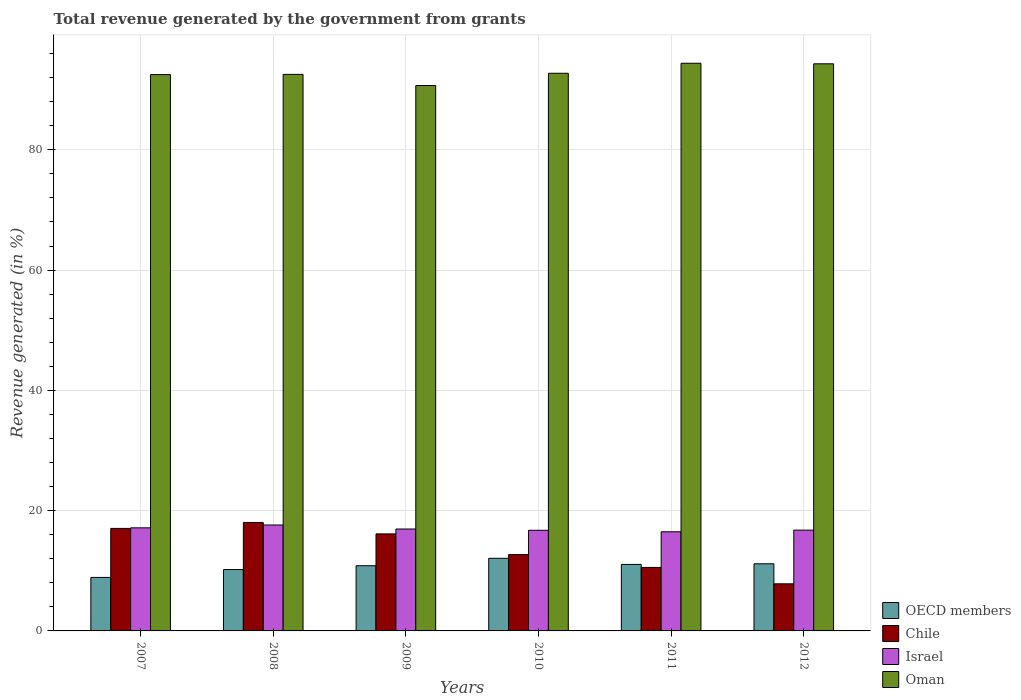How many groups of bars are there?
Give a very brief answer. 6. Are the number of bars on each tick of the X-axis equal?
Provide a short and direct response. Yes. How many bars are there on the 6th tick from the left?
Give a very brief answer. 4. In how many cases, is the number of bars for a given year not equal to the number of legend labels?
Provide a short and direct response. 0. What is the total revenue generated in OECD members in 2010?
Your response must be concise. 12.08. Across all years, what is the maximum total revenue generated in Israel?
Offer a terse response. 17.61. Across all years, what is the minimum total revenue generated in Oman?
Your answer should be compact. 90.69. In which year was the total revenue generated in OECD members minimum?
Provide a succinct answer. 2007. What is the total total revenue generated in OECD members in the graph?
Provide a succinct answer. 64.24. What is the difference between the total revenue generated in Oman in 2008 and that in 2012?
Your response must be concise. -1.76. What is the difference between the total revenue generated in Oman in 2008 and the total revenue generated in Israel in 2012?
Make the answer very short. 75.78. What is the average total revenue generated in Chile per year?
Offer a very short reply. 13.72. In the year 2008, what is the difference between the total revenue generated in Oman and total revenue generated in Israel?
Give a very brief answer. 74.93. What is the ratio of the total revenue generated in Chile in 2011 to that in 2012?
Ensure brevity in your answer.  1.35. Is the difference between the total revenue generated in Oman in 2007 and 2009 greater than the difference between the total revenue generated in Israel in 2007 and 2009?
Offer a terse response. Yes. What is the difference between the highest and the second highest total revenue generated in OECD members?
Offer a terse response. 0.91. What is the difference between the highest and the lowest total revenue generated in Chile?
Give a very brief answer. 10.2. In how many years, is the total revenue generated in Chile greater than the average total revenue generated in Chile taken over all years?
Your response must be concise. 3. What does the 3rd bar from the left in 2008 represents?
Your response must be concise. Israel. What does the 1st bar from the right in 2012 represents?
Your response must be concise. Oman. How many bars are there?
Your answer should be compact. 24. How many years are there in the graph?
Your answer should be very brief. 6. What is the difference between two consecutive major ticks on the Y-axis?
Give a very brief answer. 20. Does the graph contain any zero values?
Your answer should be very brief. No. Does the graph contain grids?
Your answer should be very brief. Yes. Where does the legend appear in the graph?
Provide a short and direct response. Bottom right. How many legend labels are there?
Provide a succinct answer. 4. How are the legend labels stacked?
Your response must be concise. Vertical. What is the title of the graph?
Your answer should be compact. Total revenue generated by the government from grants. Does "Europe(all income levels)" appear as one of the legend labels in the graph?
Offer a very short reply. No. What is the label or title of the X-axis?
Offer a very short reply. Years. What is the label or title of the Y-axis?
Make the answer very short. Revenue generated (in %). What is the Revenue generated (in %) of OECD members in 2007?
Make the answer very short. 8.9. What is the Revenue generated (in %) in Chile in 2007?
Provide a short and direct response. 17.05. What is the Revenue generated (in %) in Israel in 2007?
Your answer should be very brief. 17.14. What is the Revenue generated (in %) of Oman in 2007?
Ensure brevity in your answer.  92.51. What is the Revenue generated (in %) of OECD members in 2008?
Make the answer very short. 10.2. What is the Revenue generated (in %) in Chile in 2008?
Provide a short and direct response. 18.03. What is the Revenue generated (in %) of Israel in 2008?
Give a very brief answer. 17.61. What is the Revenue generated (in %) in Oman in 2008?
Provide a short and direct response. 92.54. What is the Revenue generated (in %) in OECD members in 2009?
Your answer should be very brief. 10.84. What is the Revenue generated (in %) in Chile in 2009?
Make the answer very short. 16.14. What is the Revenue generated (in %) of Israel in 2009?
Keep it short and to the point. 16.95. What is the Revenue generated (in %) of Oman in 2009?
Your response must be concise. 90.69. What is the Revenue generated (in %) in OECD members in 2010?
Keep it short and to the point. 12.08. What is the Revenue generated (in %) of Chile in 2010?
Your answer should be very brief. 12.7. What is the Revenue generated (in %) in Israel in 2010?
Give a very brief answer. 16.73. What is the Revenue generated (in %) in Oman in 2010?
Give a very brief answer. 92.72. What is the Revenue generated (in %) of OECD members in 2011?
Your answer should be very brief. 11.06. What is the Revenue generated (in %) of Chile in 2011?
Your answer should be compact. 10.56. What is the Revenue generated (in %) in Israel in 2011?
Keep it short and to the point. 16.48. What is the Revenue generated (in %) of Oman in 2011?
Make the answer very short. 94.39. What is the Revenue generated (in %) of OECD members in 2012?
Ensure brevity in your answer.  11.16. What is the Revenue generated (in %) of Chile in 2012?
Your response must be concise. 7.83. What is the Revenue generated (in %) of Israel in 2012?
Keep it short and to the point. 16.76. What is the Revenue generated (in %) in Oman in 2012?
Offer a very short reply. 94.3. Across all years, what is the maximum Revenue generated (in %) in OECD members?
Your answer should be compact. 12.08. Across all years, what is the maximum Revenue generated (in %) in Chile?
Make the answer very short. 18.03. Across all years, what is the maximum Revenue generated (in %) of Israel?
Make the answer very short. 17.61. Across all years, what is the maximum Revenue generated (in %) of Oman?
Keep it short and to the point. 94.39. Across all years, what is the minimum Revenue generated (in %) in OECD members?
Provide a short and direct response. 8.9. Across all years, what is the minimum Revenue generated (in %) in Chile?
Provide a short and direct response. 7.83. Across all years, what is the minimum Revenue generated (in %) of Israel?
Offer a terse response. 16.48. Across all years, what is the minimum Revenue generated (in %) in Oman?
Provide a succinct answer. 90.69. What is the total Revenue generated (in %) of OECD members in the graph?
Offer a terse response. 64.24. What is the total Revenue generated (in %) of Chile in the graph?
Offer a terse response. 82.3. What is the total Revenue generated (in %) in Israel in the graph?
Offer a very short reply. 101.68. What is the total Revenue generated (in %) of Oman in the graph?
Offer a terse response. 557.15. What is the difference between the Revenue generated (in %) in OECD members in 2007 and that in 2008?
Offer a terse response. -1.3. What is the difference between the Revenue generated (in %) in Chile in 2007 and that in 2008?
Your response must be concise. -0.99. What is the difference between the Revenue generated (in %) of Israel in 2007 and that in 2008?
Ensure brevity in your answer.  -0.47. What is the difference between the Revenue generated (in %) of Oman in 2007 and that in 2008?
Ensure brevity in your answer.  -0.04. What is the difference between the Revenue generated (in %) of OECD members in 2007 and that in 2009?
Make the answer very short. -1.94. What is the difference between the Revenue generated (in %) in Chile in 2007 and that in 2009?
Ensure brevity in your answer.  0.91. What is the difference between the Revenue generated (in %) in Israel in 2007 and that in 2009?
Your answer should be compact. 0.2. What is the difference between the Revenue generated (in %) of Oman in 2007 and that in 2009?
Ensure brevity in your answer.  1.82. What is the difference between the Revenue generated (in %) of OECD members in 2007 and that in 2010?
Offer a terse response. -3.18. What is the difference between the Revenue generated (in %) of Chile in 2007 and that in 2010?
Your answer should be compact. 4.35. What is the difference between the Revenue generated (in %) in Israel in 2007 and that in 2010?
Keep it short and to the point. 0.41. What is the difference between the Revenue generated (in %) of Oman in 2007 and that in 2010?
Make the answer very short. -0.22. What is the difference between the Revenue generated (in %) in OECD members in 2007 and that in 2011?
Your response must be concise. -2.16. What is the difference between the Revenue generated (in %) of Chile in 2007 and that in 2011?
Your answer should be very brief. 6.49. What is the difference between the Revenue generated (in %) in Israel in 2007 and that in 2011?
Provide a short and direct response. 0.66. What is the difference between the Revenue generated (in %) of Oman in 2007 and that in 2011?
Make the answer very short. -1.89. What is the difference between the Revenue generated (in %) in OECD members in 2007 and that in 2012?
Ensure brevity in your answer.  -2.26. What is the difference between the Revenue generated (in %) of Chile in 2007 and that in 2012?
Ensure brevity in your answer.  9.21. What is the difference between the Revenue generated (in %) in Israel in 2007 and that in 2012?
Give a very brief answer. 0.38. What is the difference between the Revenue generated (in %) of Oman in 2007 and that in 2012?
Keep it short and to the point. -1.79. What is the difference between the Revenue generated (in %) in OECD members in 2008 and that in 2009?
Your answer should be very brief. -0.64. What is the difference between the Revenue generated (in %) of Chile in 2008 and that in 2009?
Make the answer very short. 1.9. What is the difference between the Revenue generated (in %) of Israel in 2008 and that in 2009?
Provide a short and direct response. 0.67. What is the difference between the Revenue generated (in %) of Oman in 2008 and that in 2009?
Ensure brevity in your answer.  1.85. What is the difference between the Revenue generated (in %) in OECD members in 2008 and that in 2010?
Make the answer very short. -1.88. What is the difference between the Revenue generated (in %) in Chile in 2008 and that in 2010?
Offer a very short reply. 5.34. What is the difference between the Revenue generated (in %) in Israel in 2008 and that in 2010?
Make the answer very short. 0.88. What is the difference between the Revenue generated (in %) in Oman in 2008 and that in 2010?
Offer a terse response. -0.18. What is the difference between the Revenue generated (in %) of OECD members in 2008 and that in 2011?
Offer a very short reply. -0.86. What is the difference between the Revenue generated (in %) in Chile in 2008 and that in 2011?
Keep it short and to the point. 7.48. What is the difference between the Revenue generated (in %) of Israel in 2008 and that in 2011?
Offer a very short reply. 1.13. What is the difference between the Revenue generated (in %) in Oman in 2008 and that in 2011?
Your answer should be very brief. -1.85. What is the difference between the Revenue generated (in %) in OECD members in 2008 and that in 2012?
Your answer should be very brief. -0.96. What is the difference between the Revenue generated (in %) in Chile in 2008 and that in 2012?
Provide a short and direct response. 10.2. What is the difference between the Revenue generated (in %) of Israel in 2008 and that in 2012?
Keep it short and to the point. 0.85. What is the difference between the Revenue generated (in %) in Oman in 2008 and that in 2012?
Keep it short and to the point. -1.76. What is the difference between the Revenue generated (in %) in OECD members in 2009 and that in 2010?
Make the answer very short. -1.24. What is the difference between the Revenue generated (in %) in Chile in 2009 and that in 2010?
Offer a very short reply. 3.44. What is the difference between the Revenue generated (in %) in Israel in 2009 and that in 2010?
Provide a short and direct response. 0.21. What is the difference between the Revenue generated (in %) in Oman in 2009 and that in 2010?
Provide a short and direct response. -2.04. What is the difference between the Revenue generated (in %) in OECD members in 2009 and that in 2011?
Offer a terse response. -0.22. What is the difference between the Revenue generated (in %) in Chile in 2009 and that in 2011?
Give a very brief answer. 5.58. What is the difference between the Revenue generated (in %) of Israel in 2009 and that in 2011?
Provide a succinct answer. 0.46. What is the difference between the Revenue generated (in %) of Oman in 2009 and that in 2011?
Provide a short and direct response. -3.7. What is the difference between the Revenue generated (in %) of OECD members in 2009 and that in 2012?
Ensure brevity in your answer.  -0.32. What is the difference between the Revenue generated (in %) in Chile in 2009 and that in 2012?
Give a very brief answer. 8.3. What is the difference between the Revenue generated (in %) of Israel in 2009 and that in 2012?
Offer a very short reply. 0.19. What is the difference between the Revenue generated (in %) of Oman in 2009 and that in 2012?
Ensure brevity in your answer.  -3.61. What is the difference between the Revenue generated (in %) of OECD members in 2010 and that in 2011?
Give a very brief answer. 1.02. What is the difference between the Revenue generated (in %) of Chile in 2010 and that in 2011?
Make the answer very short. 2.14. What is the difference between the Revenue generated (in %) in Israel in 2010 and that in 2011?
Keep it short and to the point. 0.25. What is the difference between the Revenue generated (in %) of Oman in 2010 and that in 2011?
Your response must be concise. -1.67. What is the difference between the Revenue generated (in %) in OECD members in 2010 and that in 2012?
Your answer should be compact. 0.91. What is the difference between the Revenue generated (in %) in Chile in 2010 and that in 2012?
Your answer should be compact. 4.87. What is the difference between the Revenue generated (in %) in Israel in 2010 and that in 2012?
Offer a terse response. -0.03. What is the difference between the Revenue generated (in %) of Oman in 2010 and that in 2012?
Ensure brevity in your answer.  -1.57. What is the difference between the Revenue generated (in %) of OECD members in 2011 and that in 2012?
Provide a succinct answer. -0.11. What is the difference between the Revenue generated (in %) of Chile in 2011 and that in 2012?
Your answer should be compact. 2.73. What is the difference between the Revenue generated (in %) in Israel in 2011 and that in 2012?
Give a very brief answer. -0.28. What is the difference between the Revenue generated (in %) in Oman in 2011 and that in 2012?
Ensure brevity in your answer.  0.09. What is the difference between the Revenue generated (in %) in OECD members in 2007 and the Revenue generated (in %) in Chile in 2008?
Offer a terse response. -9.14. What is the difference between the Revenue generated (in %) in OECD members in 2007 and the Revenue generated (in %) in Israel in 2008?
Your answer should be compact. -8.72. What is the difference between the Revenue generated (in %) of OECD members in 2007 and the Revenue generated (in %) of Oman in 2008?
Ensure brevity in your answer.  -83.64. What is the difference between the Revenue generated (in %) of Chile in 2007 and the Revenue generated (in %) of Israel in 2008?
Offer a terse response. -0.57. What is the difference between the Revenue generated (in %) of Chile in 2007 and the Revenue generated (in %) of Oman in 2008?
Your response must be concise. -75.49. What is the difference between the Revenue generated (in %) in Israel in 2007 and the Revenue generated (in %) in Oman in 2008?
Your response must be concise. -75.4. What is the difference between the Revenue generated (in %) of OECD members in 2007 and the Revenue generated (in %) of Chile in 2009?
Ensure brevity in your answer.  -7.24. What is the difference between the Revenue generated (in %) in OECD members in 2007 and the Revenue generated (in %) in Israel in 2009?
Your response must be concise. -8.05. What is the difference between the Revenue generated (in %) of OECD members in 2007 and the Revenue generated (in %) of Oman in 2009?
Offer a terse response. -81.79. What is the difference between the Revenue generated (in %) in Chile in 2007 and the Revenue generated (in %) in Israel in 2009?
Make the answer very short. 0.1. What is the difference between the Revenue generated (in %) of Chile in 2007 and the Revenue generated (in %) of Oman in 2009?
Give a very brief answer. -73.64. What is the difference between the Revenue generated (in %) of Israel in 2007 and the Revenue generated (in %) of Oman in 2009?
Ensure brevity in your answer.  -73.55. What is the difference between the Revenue generated (in %) in OECD members in 2007 and the Revenue generated (in %) in Chile in 2010?
Keep it short and to the point. -3.8. What is the difference between the Revenue generated (in %) in OECD members in 2007 and the Revenue generated (in %) in Israel in 2010?
Your answer should be compact. -7.83. What is the difference between the Revenue generated (in %) of OECD members in 2007 and the Revenue generated (in %) of Oman in 2010?
Your answer should be very brief. -83.83. What is the difference between the Revenue generated (in %) in Chile in 2007 and the Revenue generated (in %) in Israel in 2010?
Your answer should be very brief. 0.31. What is the difference between the Revenue generated (in %) of Chile in 2007 and the Revenue generated (in %) of Oman in 2010?
Give a very brief answer. -75.68. What is the difference between the Revenue generated (in %) in Israel in 2007 and the Revenue generated (in %) in Oman in 2010?
Keep it short and to the point. -75.58. What is the difference between the Revenue generated (in %) of OECD members in 2007 and the Revenue generated (in %) of Chile in 2011?
Your response must be concise. -1.66. What is the difference between the Revenue generated (in %) of OECD members in 2007 and the Revenue generated (in %) of Israel in 2011?
Ensure brevity in your answer.  -7.59. What is the difference between the Revenue generated (in %) of OECD members in 2007 and the Revenue generated (in %) of Oman in 2011?
Provide a succinct answer. -85.49. What is the difference between the Revenue generated (in %) of Chile in 2007 and the Revenue generated (in %) of Israel in 2011?
Provide a succinct answer. 0.56. What is the difference between the Revenue generated (in %) of Chile in 2007 and the Revenue generated (in %) of Oman in 2011?
Offer a terse response. -77.35. What is the difference between the Revenue generated (in %) of Israel in 2007 and the Revenue generated (in %) of Oman in 2011?
Keep it short and to the point. -77.25. What is the difference between the Revenue generated (in %) of OECD members in 2007 and the Revenue generated (in %) of Chile in 2012?
Your answer should be compact. 1.07. What is the difference between the Revenue generated (in %) in OECD members in 2007 and the Revenue generated (in %) in Israel in 2012?
Your answer should be compact. -7.86. What is the difference between the Revenue generated (in %) of OECD members in 2007 and the Revenue generated (in %) of Oman in 2012?
Make the answer very short. -85.4. What is the difference between the Revenue generated (in %) of Chile in 2007 and the Revenue generated (in %) of Israel in 2012?
Offer a very short reply. 0.29. What is the difference between the Revenue generated (in %) of Chile in 2007 and the Revenue generated (in %) of Oman in 2012?
Provide a succinct answer. -77.25. What is the difference between the Revenue generated (in %) of Israel in 2007 and the Revenue generated (in %) of Oman in 2012?
Your answer should be very brief. -77.16. What is the difference between the Revenue generated (in %) in OECD members in 2008 and the Revenue generated (in %) in Chile in 2009?
Offer a very short reply. -5.93. What is the difference between the Revenue generated (in %) in OECD members in 2008 and the Revenue generated (in %) in Israel in 2009?
Provide a succinct answer. -6.74. What is the difference between the Revenue generated (in %) of OECD members in 2008 and the Revenue generated (in %) of Oman in 2009?
Provide a short and direct response. -80.49. What is the difference between the Revenue generated (in %) of Chile in 2008 and the Revenue generated (in %) of Israel in 2009?
Make the answer very short. 1.09. What is the difference between the Revenue generated (in %) of Chile in 2008 and the Revenue generated (in %) of Oman in 2009?
Offer a very short reply. -72.65. What is the difference between the Revenue generated (in %) in Israel in 2008 and the Revenue generated (in %) in Oman in 2009?
Your answer should be very brief. -73.07. What is the difference between the Revenue generated (in %) of OECD members in 2008 and the Revenue generated (in %) of Chile in 2010?
Your answer should be compact. -2.49. What is the difference between the Revenue generated (in %) in OECD members in 2008 and the Revenue generated (in %) in Israel in 2010?
Your answer should be compact. -6.53. What is the difference between the Revenue generated (in %) of OECD members in 2008 and the Revenue generated (in %) of Oman in 2010?
Offer a very short reply. -82.52. What is the difference between the Revenue generated (in %) in Chile in 2008 and the Revenue generated (in %) in Israel in 2010?
Provide a short and direct response. 1.3. What is the difference between the Revenue generated (in %) in Chile in 2008 and the Revenue generated (in %) in Oman in 2010?
Offer a very short reply. -74.69. What is the difference between the Revenue generated (in %) in Israel in 2008 and the Revenue generated (in %) in Oman in 2010?
Ensure brevity in your answer.  -75.11. What is the difference between the Revenue generated (in %) in OECD members in 2008 and the Revenue generated (in %) in Chile in 2011?
Offer a very short reply. -0.36. What is the difference between the Revenue generated (in %) in OECD members in 2008 and the Revenue generated (in %) in Israel in 2011?
Provide a succinct answer. -6.28. What is the difference between the Revenue generated (in %) in OECD members in 2008 and the Revenue generated (in %) in Oman in 2011?
Offer a very short reply. -84.19. What is the difference between the Revenue generated (in %) of Chile in 2008 and the Revenue generated (in %) of Israel in 2011?
Your response must be concise. 1.55. What is the difference between the Revenue generated (in %) of Chile in 2008 and the Revenue generated (in %) of Oman in 2011?
Offer a terse response. -76.36. What is the difference between the Revenue generated (in %) in Israel in 2008 and the Revenue generated (in %) in Oman in 2011?
Give a very brief answer. -76.78. What is the difference between the Revenue generated (in %) of OECD members in 2008 and the Revenue generated (in %) of Chile in 2012?
Offer a terse response. 2.37. What is the difference between the Revenue generated (in %) in OECD members in 2008 and the Revenue generated (in %) in Israel in 2012?
Provide a short and direct response. -6.56. What is the difference between the Revenue generated (in %) of OECD members in 2008 and the Revenue generated (in %) of Oman in 2012?
Offer a very short reply. -84.1. What is the difference between the Revenue generated (in %) in Chile in 2008 and the Revenue generated (in %) in Israel in 2012?
Your answer should be compact. 1.28. What is the difference between the Revenue generated (in %) in Chile in 2008 and the Revenue generated (in %) in Oman in 2012?
Offer a terse response. -76.26. What is the difference between the Revenue generated (in %) in Israel in 2008 and the Revenue generated (in %) in Oman in 2012?
Offer a terse response. -76.69. What is the difference between the Revenue generated (in %) in OECD members in 2009 and the Revenue generated (in %) in Chile in 2010?
Offer a very short reply. -1.86. What is the difference between the Revenue generated (in %) in OECD members in 2009 and the Revenue generated (in %) in Israel in 2010?
Provide a short and direct response. -5.89. What is the difference between the Revenue generated (in %) in OECD members in 2009 and the Revenue generated (in %) in Oman in 2010?
Your response must be concise. -81.88. What is the difference between the Revenue generated (in %) in Chile in 2009 and the Revenue generated (in %) in Israel in 2010?
Make the answer very short. -0.6. What is the difference between the Revenue generated (in %) in Chile in 2009 and the Revenue generated (in %) in Oman in 2010?
Your response must be concise. -76.59. What is the difference between the Revenue generated (in %) in Israel in 2009 and the Revenue generated (in %) in Oman in 2010?
Your answer should be very brief. -75.78. What is the difference between the Revenue generated (in %) of OECD members in 2009 and the Revenue generated (in %) of Chile in 2011?
Make the answer very short. 0.28. What is the difference between the Revenue generated (in %) of OECD members in 2009 and the Revenue generated (in %) of Israel in 2011?
Ensure brevity in your answer.  -5.64. What is the difference between the Revenue generated (in %) of OECD members in 2009 and the Revenue generated (in %) of Oman in 2011?
Offer a terse response. -83.55. What is the difference between the Revenue generated (in %) of Chile in 2009 and the Revenue generated (in %) of Israel in 2011?
Make the answer very short. -0.35. What is the difference between the Revenue generated (in %) in Chile in 2009 and the Revenue generated (in %) in Oman in 2011?
Offer a terse response. -78.26. What is the difference between the Revenue generated (in %) in Israel in 2009 and the Revenue generated (in %) in Oman in 2011?
Offer a very short reply. -77.45. What is the difference between the Revenue generated (in %) in OECD members in 2009 and the Revenue generated (in %) in Chile in 2012?
Your response must be concise. 3.01. What is the difference between the Revenue generated (in %) of OECD members in 2009 and the Revenue generated (in %) of Israel in 2012?
Ensure brevity in your answer.  -5.92. What is the difference between the Revenue generated (in %) in OECD members in 2009 and the Revenue generated (in %) in Oman in 2012?
Provide a succinct answer. -83.46. What is the difference between the Revenue generated (in %) in Chile in 2009 and the Revenue generated (in %) in Israel in 2012?
Your response must be concise. -0.62. What is the difference between the Revenue generated (in %) of Chile in 2009 and the Revenue generated (in %) of Oman in 2012?
Offer a very short reply. -78.16. What is the difference between the Revenue generated (in %) in Israel in 2009 and the Revenue generated (in %) in Oman in 2012?
Your answer should be very brief. -77.35. What is the difference between the Revenue generated (in %) of OECD members in 2010 and the Revenue generated (in %) of Chile in 2011?
Give a very brief answer. 1.52. What is the difference between the Revenue generated (in %) of OECD members in 2010 and the Revenue generated (in %) of Israel in 2011?
Offer a terse response. -4.41. What is the difference between the Revenue generated (in %) in OECD members in 2010 and the Revenue generated (in %) in Oman in 2011?
Keep it short and to the point. -82.31. What is the difference between the Revenue generated (in %) in Chile in 2010 and the Revenue generated (in %) in Israel in 2011?
Give a very brief answer. -3.79. What is the difference between the Revenue generated (in %) in Chile in 2010 and the Revenue generated (in %) in Oman in 2011?
Your answer should be compact. -81.69. What is the difference between the Revenue generated (in %) of Israel in 2010 and the Revenue generated (in %) of Oman in 2011?
Give a very brief answer. -77.66. What is the difference between the Revenue generated (in %) in OECD members in 2010 and the Revenue generated (in %) in Chile in 2012?
Give a very brief answer. 4.25. What is the difference between the Revenue generated (in %) in OECD members in 2010 and the Revenue generated (in %) in Israel in 2012?
Offer a terse response. -4.68. What is the difference between the Revenue generated (in %) in OECD members in 2010 and the Revenue generated (in %) in Oman in 2012?
Offer a very short reply. -82.22. What is the difference between the Revenue generated (in %) in Chile in 2010 and the Revenue generated (in %) in Israel in 2012?
Your answer should be compact. -4.06. What is the difference between the Revenue generated (in %) of Chile in 2010 and the Revenue generated (in %) of Oman in 2012?
Ensure brevity in your answer.  -81.6. What is the difference between the Revenue generated (in %) of Israel in 2010 and the Revenue generated (in %) of Oman in 2012?
Ensure brevity in your answer.  -77.57. What is the difference between the Revenue generated (in %) in OECD members in 2011 and the Revenue generated (in %) in Chile in 2012?
Make the answer very short. 3.23. What is the difference between the Revenue generated (in %) of OECD members in 2011 and the Revenue generated (in %) of Israel in 2012?
Your answer should be compact. -5.7. What is the difference between the Revenue generated (in %) of OECD members in 2011 and the Revenue generated (in %) of Oman in 2012?
Offer a terse response. -83.24. What is the difference between the Revenue generated (in %) of Chile in 2011 and the Revenue generated (in %) of Israel in 2012?
Make the answer very short. -6.2. What is the difference between the Revenue generated (in %) in Chile in 2011 and the Revenue generated (in %) in Oman in 2012?
Keep it short and to the point. -83.74. What is the difference between the Revenue generated (in %) of Israel in 2011 and the Revenue generated (in %) of Oman in 2012?
Provide a short and direct response. -77.82. What is the average Revenue generated (in %) in OECD members per year?
Give a very brief answer. 10.71. What is the average Revenue generated (in %) in Chile per year?
Provide a short and direct response. 13.72. What is the average Revenue generated (in %) in Israel per year?
Ensure brevity in your answer.  16.95. What is the average Revenue generated (in %) of Oman per year?
Your answer should be very brief. 92.86. In the year 2007, what is the difference between the Revenue generated (in %) in OECD members and Revenue generated (in %) in Chile?
Offer a very short reply. -8.15. In the year 2007, what is the difference between the Revenue generated (in %) in OECD members and Revenue generated (in %) in Israel?
Offer a terse response. -8.24. In the year 2007, what is the difference between the Revenue generated (in %) of OECD members and Revenue generated (in %) of Oman?
Your answer should be compact. -83.61. In the year 2007, what is the difference between the Revenue generated (in %) of Chile and Revenue generated (in %) of Israel?
Ensure brevity in your answer.  -0.1. In the year 2007, what is the difference between the Revenue generated (in %) of Chile and Revenue generated (in %) of Oman?
Give a very brief answer. -75.46. In the year 2007, what is the difference between the Revenue generated (in %) of Israel and Revenue generated (in %) of Oman?
Offer a very short reply. -75.36. In the year 2008, what is the difference between the Revenue generated (in %) of OECD members and Revenue generated (in %) of Chile?
Offer a very short reply. -7.83. In the year 2008, what is the difference between the Revenue generated (in %) of OECD members and Revenue generated (in %) of Israel?
Your answer should be very brief. -7.41. In the year 2008, what is the difference between the Revenue generated (in %) in OECD members and Revenue generated (in %) in Oman?
Provide a succinct answer. -82.34. In the year 2008, what is the difference between the Revenue generated (in %) in Chile and Revenue generated (in %) in Israel?
Provide a short and direct response. 0.42. In the year 2008, what is the difference between the Revenue generated (in %) in Chile and Revenue generated (in %) in Oman?
Offer a very short reply. -74.51. In the year 2008, what is the difference between the Revenue generated (in %) in Israel and Revenue generated (in %) in Oman?
Your response must be concise. -74.93. In the year 2009, what is the difference between the Revenue generated (in %) in OECD members and Revenue generated (in %) in Chile?
Ensure brevity in your answer.  -5.29. In the year 2009, what is the difference between the Revenue generated (in %) of OECD members and Revenue generated (in %) of Israel?
Your answer should be compact. -6.1. In the year 2009, what is the difference between the Revenue generated (in %) of OECD members and Revenue generated (in %) of Oman?
Your response must be concise. -79.85. In the year 2009, what is the difference between the Revenue generated (in %) of Chile and Revenue generated (in %) of Israel?
Offer a very short reply. -0.81. In the year 2009, what is the difference between the Revenue generated (in %) of Chile and Revenue generated (in %) of Oman?
Offer a very short reply. -74.55. In the year 2009, what is the difference between the Revenue generated (in %) in Israel and Revenue generated (in %) in Oman?
Your response must be concise. -73.74. In the year 2010, what is the difference between the Revenue generated (in %) of OECD members and Revenue generated (in %) of Chile?
Ensure brevity in your answer.  -0.62. In the year 2010, what is the difference between the Revenue generated (in %) in OECD members and Revenue generated (in %) in Israel?
Provide a short and direct response. -4.66. In the year 2010, what is the difference between the Revenue generated (in %) in OECD members and Revenue generated (in %) in Oman?
Your answer should be very brief. -80.65. In the year 2010, what is the difference between the Revenue generated (in %) in Chile and Revenue generated (in %) in Israel?
Keep it short and to the point. -4.04. In the year 2010, what is the difference between the Revenue generated (in %) in Chile and Revenue generated (in %) in Oman?
Offer a terse response. -80.03. In the year 2010, what is the difference between the Revenue generated (in %) in Israel and Revenue generated (in %) in Oman?
Provide a short and direct response. -75.99. In the year 2011, what is the difference between the Revenue generated (in %) of OECD members and Revenue generated (in %) of Chile?
Ensure brevity in your answer.  0.5. In the year 2011, what is the difference between the Revenue generated (in %) of OECD members and Revenue generated (in %) of Israel?
Offer a terse response. -5.43. In the year 2011, what is the difference between the Revenue generated (in %) of OECD members and Revenue generated (in %) of Oman?
Keep it short and to the point. -83.33. In the year 2011, what is the difference between the Revenue generated (in %) in Chile and Revenue generated (in %) in Israel?
Keep it short and to the point. -5.93. In the year 2011, what is the difference between the Revenue generated (in %) of Chile and Revenue generated (in %) of Oman?
Provide a succinct answer. -83.83. In the year 2011, what is the difference between the Revenue generated (in %) in Israel and Revenue generated (in %) in Oman?
Ensure brevity in your answer.  -77.91. In the year 2012, what is the difference between the Revenue generated (in %) of OECD members and Revenue generated (in %) of Chile?
Your response must be concise. 3.33. In the year 2012, what is the difference between the Revenue generated (in %) in OECD members and Revenue generated (in %) in Israel?
Your response must be concise. -5.6. In the year 2012, what is the difference between the Revenue generated (in %) in OECD members and Revenue generated (in %) in Oman?
Offer a very short reply. -83.14. In the year 2012, what is the difference between the Revenue generated (in %) in Chile and Revenue generated (in %) in Israel?
Your response must be concise. -8.93. In the year 2012, what is the difference between the Revenue generated (in %) of Chile and Revenue generated (in %) of Oman?
Keep it short and to the point. -86.47. In the year 2012, what is the difference between the Revenue generated (in %) of Israel and Revenue generated (in %) of Oman?
Keep it short and to the point. -77.54. What is the ratio of the Revenue generated (in %) in OECD members in 2007 to that in 2008?
Make the answer very short. 0.87. What is the ratio of the Revenue generated (in %) of Chile in 2007 to that in 2008?
Provide a short and direct response. 0.95. What is the ratio of the Revenue generated (in %) of Israel in 2007 to that in 2008?
Offer a very short reply. 0.97. What is the ratio of the Revenue generated (in %) of Oman in 2007 to that in 2008?
Offer a very short reply. 1. What is the ratio of the Revenue generated (in %) in OECD members in 2007 to that in 2009?
Keep it short and to the point. 0.82. What is the ratio of the Revenue generated (in %) in Chile in 2007 to that in 2009?
Your response must be concise. 1.06. What is the ratio of the Revenue generated (in %) of Israel in 2007 to that in 2009?
Make the answer very short. 1.01. What is the ratio of the Revenue generated (in %) in Oman in 2007 to that in 2009?
Provide a short and direct response. 1.02. What is the ratio of the Revenue generated (in %) of OECD members in 2007 to that in 2010?
Your answer should be very brief. 0.74. What is the ratio of the Revenue generated (in %) of Chile in 2007 to that in 2010?
Make the answer very short. 1.34. What is the ratio of the Revenue generated (in %) of Israel in 2007 to that in 2010?
Your response must be concise. 1.02. What is the ratio of the Revenue generated (in %) in OECD members in 2007 to that in 2011?
Your response must be concise. 0.8. What is the ratio of the Revenue generated (in %) in Chile in 2007 to that in 2011?
Offer a very short reply. 1.61. What is the ratio of the Revenue generated (in %) of Israel in 2007 to that in 2011?
Offer a very short reply. 1.04. What is the ratio of the Revenue generated (in %) of Oman in 2007 to that in 2011?
Your answer should be very brief. 0.98. What is the ratio of the Revenue generated (in %) in OECD members in 2007 to that in 2012?
Ensure brevity in your answer.  0.8. What is the ratio of the Revenue generated (in %) of Chile in 2007 to that in 2012?
Offer a very short reply. 2.18. What is the ratio of the Revenue generated (in %) of Israel in 2007 to that in 2012?
Offer a terse response. 1.02. What is the ratio of the Revenue generated (in %) of Oman in 2007 to that in 2012?
Offer a very short reply. 0.98. What is the ratio of the Revenue generated (in %) of OECD members in 2008 to that in 2009?
Ensure brevity in your answer.  0.94. What is the ratio of the Revenue generated (in %) of Chile in 2008 to that in 2009?
Make the answer very short. 1.12. What is the ratio of the Revenue generated (in %) of Israel in 2008 to that in 2009?
Make the answer very short. 1.04. What is the ratio of the Revenue generated (in %) of Oman in 2008 to that in 2009?
Your answer should be very brief. 1.02. What is the ratio of the Revenue generated (in %) of OECD members in 2008 to that in 2010?
Make the answer very short. 0.84. What is the ratio of the Revenue generated (in %) of Chile in 2008 to that in 2010?
Offer a terse response. 1.42. What is the ratio of the Revenue generated (in %) in Israel in 2008 to that in 2010?
Your response must be concise. 1.05. What is the ratio of the Revenue generated (in %) of OECD members in 2008 to that in 2011?
Provide a succinct answer. 0.92. What is the ratio of the Revenue generated (in %) of Chile in 2008 to that in 2011?
Offer a very short reply. 1.71. What is the ratio of the Revenue generated (in %) in Israel in 2008 to that in 2011?
Keep it short and to the point. 1.07. What is the ratio of the Revenue generated (in %) of Oman in 2008 to that in 2011?
Offer a terse response. 0.98. What is the ratio of the Revenue generated (in %) in OECD members in 2008 to that in 2012?
Your answer should be compact. 0.91. What is the ratio of the Revenue generated (in %) of Chile in 2008 to that in 2012?
Give a very brief answer. 2.3. What is the ratio of the Revenue generated (in %) of Israel in 2008 to that in 2012?
Your response must be concise. 1.05. What is the ratio of the Revenue generated (in %) of Oman in 2008 to that in 2012?
Give a very brief answer. 0.98. What is the ratio of the Revenue generated (in %) in OECD members in 2009 to that in 2010?
Offer a terse response. 0.9. What is the ratio of the Revenue generated (in %) of Chile in 2009 to that in 2010?
Make the answer very short. 1.27. What is the ratio of the Revenue generated (in %) of Israel in 2009 to that in 2010?
Offer a very short reply. 1.01. What is the ratio of the Revenue generated (in %) in Oman in 2009 to that in 2010?
Your answer should be compact. 0.98. What is the ratio of the Revenue generated (in %) of OECD members in 2009 to that in 2011?
Your answer should be very brief. 0.98. What is the ratio of the Revenue generated (in %) in Chile in 2009 to that in 2011?
Provide a succinct answer. 1.53. What is the ratio of the Revenue generated (in %) of Israel in 2009 to that in 2011?
Your answer should be very brief. 1.03. What is the ratio of the Revenue generated (in %) in Oman in 2009 to that in 2011?
Offer a terse response. 0.96. What is the ratio of the Revenue generated (in %) in OECD members in 2009 to that in 2012?
Your answer should be compact. 0.97. What is the ratio of the Revenue generated (in %) in Chile in 2009 to that in 2012?
Offer a very short reply. 2.06. What is the ratio of the Revenue generated (in %) in Israel in 2009 to that in 2012?
Provide a short and direct response. 1.01. What is the ratio of the Revenue generated (in %) of Oman in 2009 to that in 2012?
Keep it short and to the point. 0.96. What is the ratio of the Revenue generated (in %) in OECD members in 2010 to that in 2011?
Provide a succinct answer. 1.09. What is the ratio of the Revenue generated (in %) in Chile in 2010 to that in 2011?
Make the answer very short. 1.2. What is the ratio of the Revenue generated (in %) in Israel in 2010 to that in 2011?
Ensure brevity in your answer.  1.02. What is the ratio of the Revenue generated (in %) of Oman in 2010 to that in 2011?
Make the answer very short. 0.98. What is the ratio of the Revenue generated (in %) in OECD members in 2010 to that in 2012?
Offer a terse response. 1.08. What is the ratio of the Revenue generated (in %) of Chile in 2010 to that in 2012?
Your answer should be very brief. 1.62. What is the ratio of the Revenue generated (in %) in Israel in 2010 to that in 2012?
Keep it short and to the point. 1. What is the ratio of the Revenue generated (in %) of Oman in 2010 to that in 2012?
Keep it short and to the point. 0.98. What is the ratio of the Revenue generated (in %) of Chile in 2011 to that in 2012?
Your answer should be compact. 1.35. What is the ratio of the Revenue generated (in %) in Israel in 2011 to that in 2012?
Your answer should be very brief. 0.98. What is the ratio of the Revenue generated (in %) in Oman in 2011 to that in 2012?
Your response must be concise. 1. What is the difference between the highest and the second highest Revenue generated (in %) in OECD members?
Give a very brief answer. 0.91. What is the difference between the highest and the second highest Revenue generated (in %) in Chile?
Your answer should be very brief. 0.99. What is the difference between the highest and the second highest Revenue generated (in %) of Israel?
Offer a terse response. 0.47. What is the difference between the highest and the second highest Revenue generated (in %) of Oman?
Make the answer very short. 0.09. What is the difference between the highest and the lowest Revenue generated (in %) of OECD members?
Make the answer very short. 3.18. What is the difference between the highest and the lowest Revenue generated (in %) of Chile?
Keep it short and to the point. 10.2. What is the difference between the highest and the lowest Revenue generated (in %) of Israel?
Offer a terse response. 1.13. What is the difference between the highest and the lowest Revenue generated (in %) of Oman?
Provide a short and direct response. 3.7. 